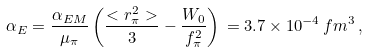<formula> <loc_0><loc_0><loc_500><loc_500>\alpha _ { E } = \frac { \alpha _ { E M } } { \mu _ { \pi } } \left ( \frac { < r _ { \pi } ^ { 2 } > } { 3 } - \frac { W _ { 0 } } { f _ { \pi } ^ { 2 } } \right ) \, = 3 . 7 \times 1 0 ^ { - 4 } \, f m ^ { 3 } \, ,</formula> 